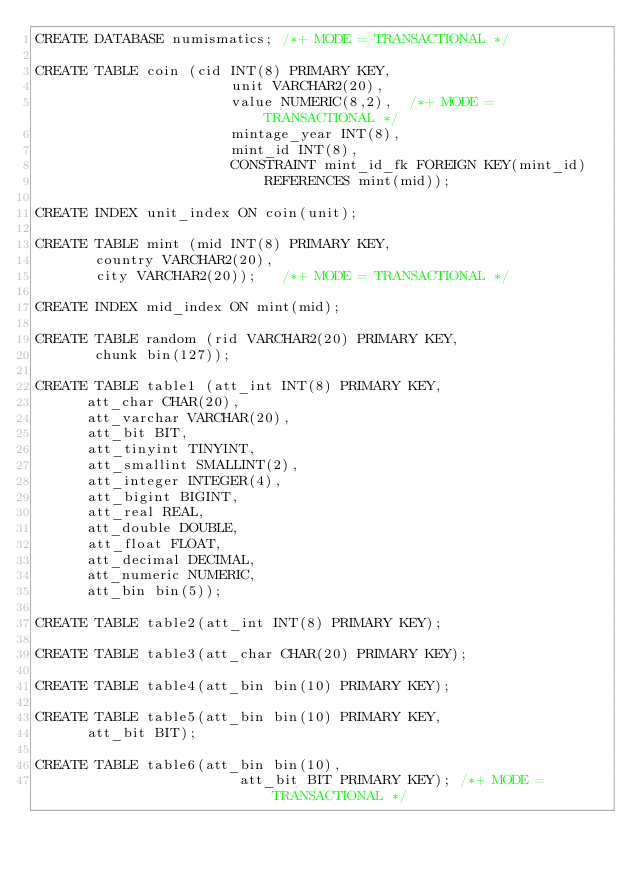<code> <loc_0><loc_0><loc_500><loc_500><_SQL_>CREATE DATABASE numismatics; /*+ MODE = TRANSACTIONAL */ 

CREATE TABLE coin (cid INT(8) PRIMARY KEY,
                       unit VARCHAR2(20),
                       value NUMERIC(8,2),  /*+ MODE = TRANSACTIONAL */
                       mintage_year INT(8),
                       mint_id INT(8),
                       CONSTRAINT mint_id_fk FOREIGN KEY(mint_id)
                           REFERENCES mint(mid));

CREATE INDEX unit_index ON coin(unit);

CREATE TABLE mint (mid INT(8) PRIMARY KEY,
       country VARCHAR2(20),
       city VARCHAR2(20));   /*+ MODE = TRANSACTIONAL */

CREATE INDEX mid_index ON mint(mid); 

CREATE TABLE random (rid VARCHAR2(20) PRIMARY KEY,
       chunk bin(127));

CREATE TABLE table1 (att_int INT(8) PRIMARY KEY,
		 	att_char CHAR(20),
			att_varchar VARCHAR(20),
			att_bit BIT,
			att_tinyint TINYINT,
			att_smallint SMALLINT(2),
			att_integer INTEGER(4),
			att_bigint BIGINT,
			att_real REAL,
			att_double DOUBLE,
			att_float FLOAT,
			att_decimal DECIMAL,
			att_numeric NUMERIC,
			att_bin bin(5));

CREATE TABLE table2(att_int INT(8) PRIMARY KEY);
		
CREATE TABLE table3(att_char CHAR(20) PRIMARY KEY);

CREATE TABLE table4(att_bin bin(10) PRIMARY KEY);

CREATE TABLE table5(att_bin bin(10) PRIMARY KEY,
			att_bit BIT);

CREATE TABLE table6(att_bin bin(10),
                        att_bit BIT PRIMARY KEY); /*+ MODE = TRANSACTIONAL */
</code> 